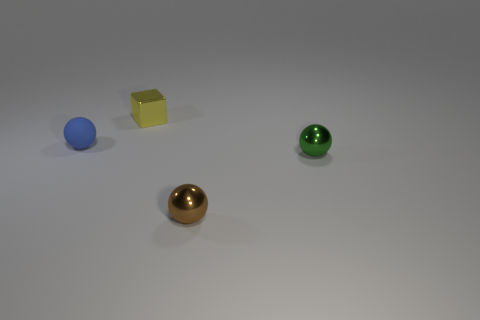The brown object has what size?
Your answer should be compact. Small. There is a thing behind the tiny sphere to the left of the brown object; what size is it?
Make the answer very short. Small. There is a tiny object that is behind the object left of the tiny shiny object that is left of the brown shiny sphere; what shape is it?
Provide a short and direct response. Cube. What is the material of the small brown thing that is the same shape as the small green metal thing?
Your answer should be very brief. Metal. How many small red metallic objects are there?
Provide a short and direct response. 0. What shape is the metal thing that is behind the blue thing?
Your answer should be compact. Cube. What is the color of the tiny metal object behind the tiny object left of the tiny object that is behind the blue object?
Your response must be concise. Yellow. There is a tiny yellow thing that is made of the same material as the tiny green object; what shape is it?
Provide a short and direct response. Cube. Are there fewer yellow metal cubes than small blue metal cylinders?
Ensure brevity in your answer.  No. Do the green sphere and the small blue object have the same material?
Offer a terse response. No. 